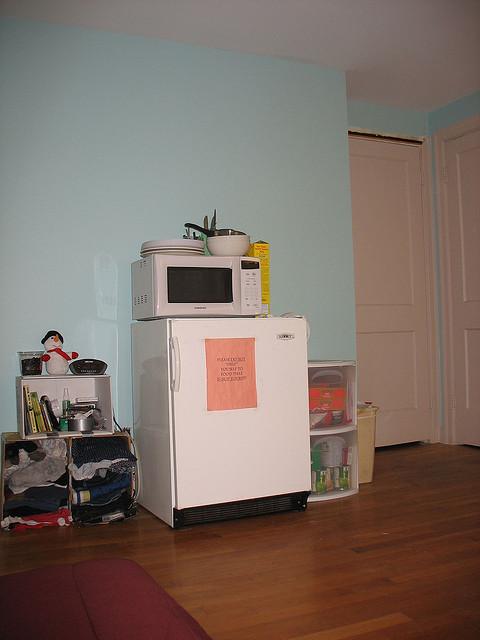Is the snowman wearing a scarf?
Give a very brief answer. Yes. What is the microwave sitting on?
Write a very short answer. Refrigerator. Is this a kitchen?
Write a very short answer. No. What supplies are on the microwave?
Short answer required. Plates. 